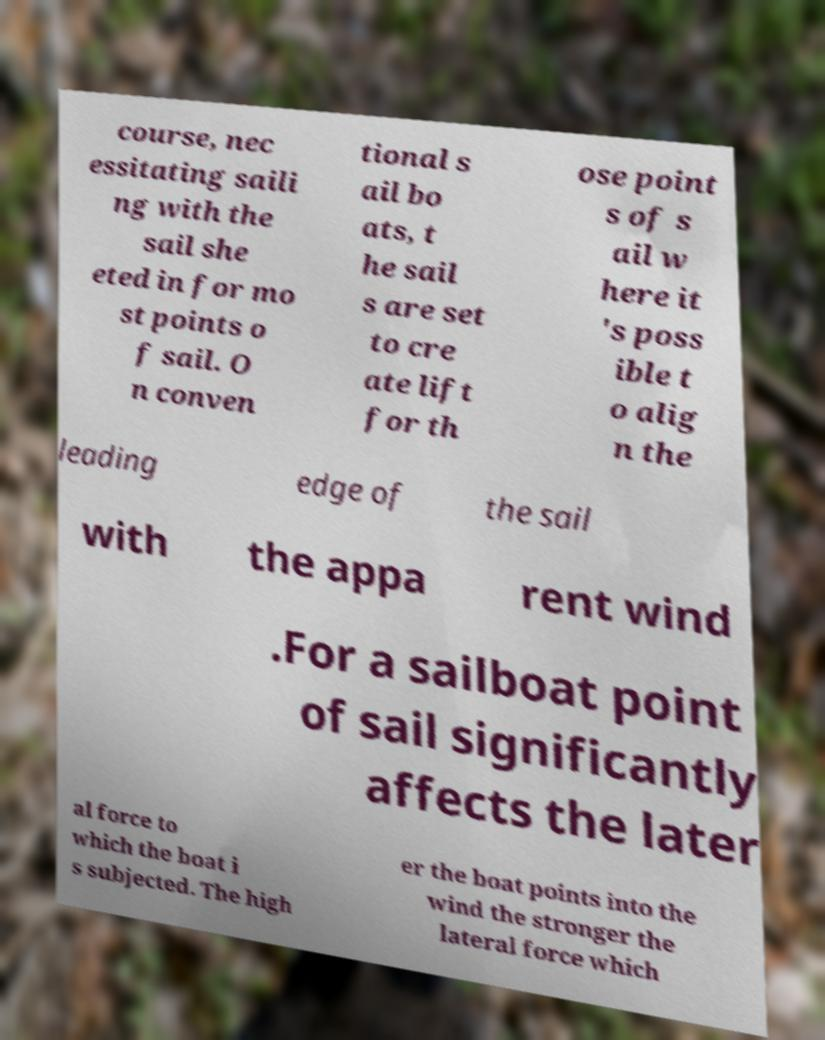Please identify and transcribe the text found in this image. course, nec essitating saili ng with the sail she eted in for mo st points o f sail. O n conven tional s ail bo ats, t he sail s are set to cre ate lift for th ose point s of s ail w here it 's poss ible t o alig n the leading edge of the sail with the appa rent wind .For a sailboat point of sail significantly affects the later al force to which the boat i s subjected. The high er the boat points into the wind the stronger the lateral force which 